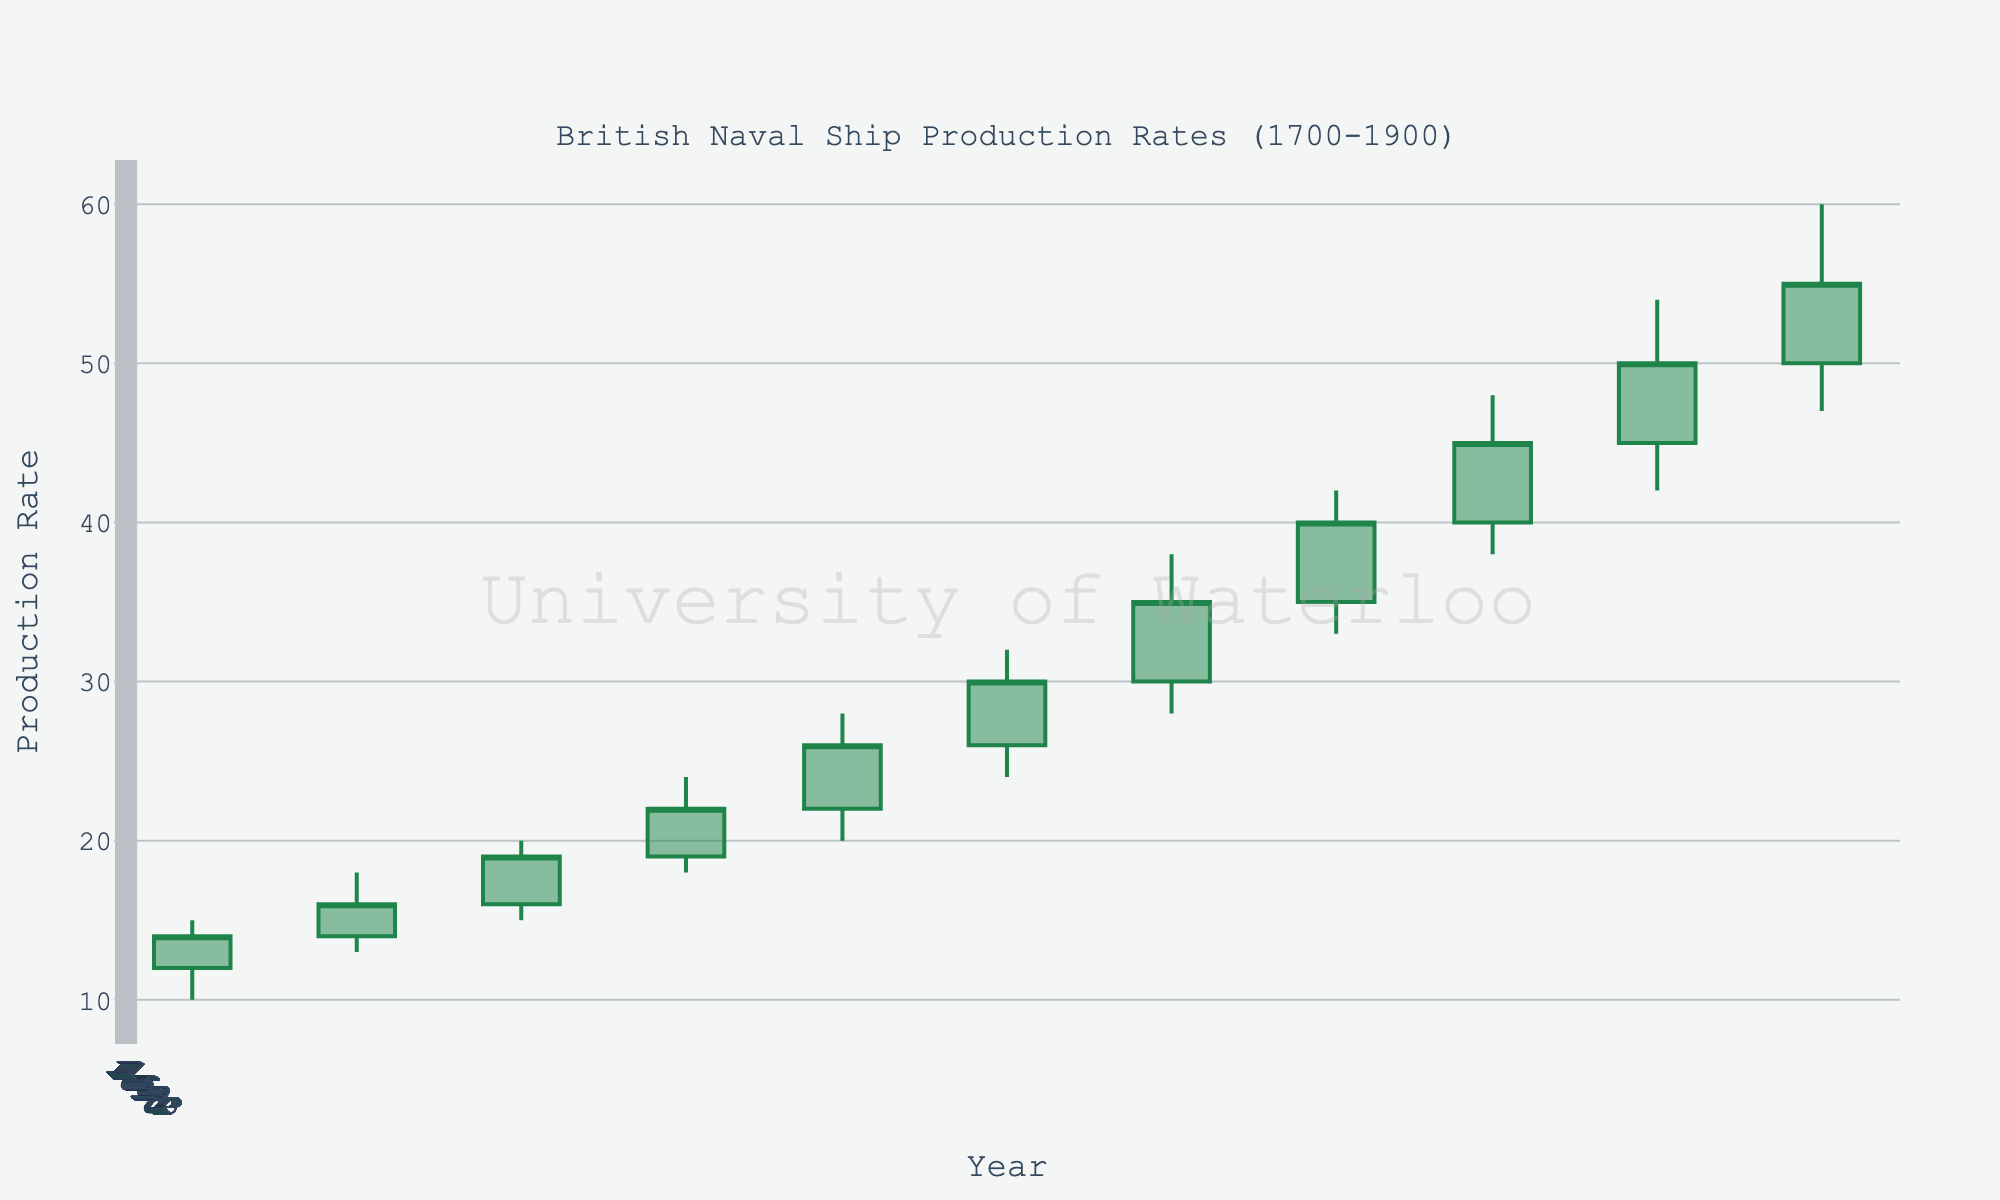What's the title of the plot? The title is displayed at the top of the chart, indicating the thematic focus of the data.
Answer: British Naval Ship Production Rates (1700-1900) How many data points are present in the chart? The chart has quarterly data points from 1700 to 1900. Each data point represents a specific quarter within a year.
Answer: 11 What is the highest production rate observed in the chart? The chart's y-axis shows the production rates, and the data points indicate the highs.
Answer: 60 In which year did the production rate open at 40? The open values are marked at the beginning of each time period. By observing the data points alongside the years, we determine the year.
Answer: 1860 Compare the closing production rates of 1700-Q1 and 1800-Q2. Which one is higher? By comparing the close values of the two specified years, we see which is higher.
Answer: 1800-Q2 What is the range of production rates in 1780-Q1? The range can be found by subtracting the low value from the high value for 1780-Q1.
Answer: 28 (28-20) How does the average opening rate in 1700-Q1 compare to the average opening rate in 1840-Q4? Find the opening rates, sum them, and divide by the number of quarters for a simple average comparison.
Answer: 1840-Q4 is higher (35 vs. 12) In which year did the production rate close at 45? Check the closing values for each quarter-year entry and identify the corresponding year.
Answer: 1860 Which quarter shows the most significant increase in the closing value compared to its opening value? Subtract the opening value from the closing value for each quarter and find the largest difference.
Answer: 1880-Q2 (50-45=5) What trend can you observe in the overall production rates from 1700 to 1900? By analyzing the increase or decrease in production rates over time, we determine the generalized trend.
Answer: Increasing 